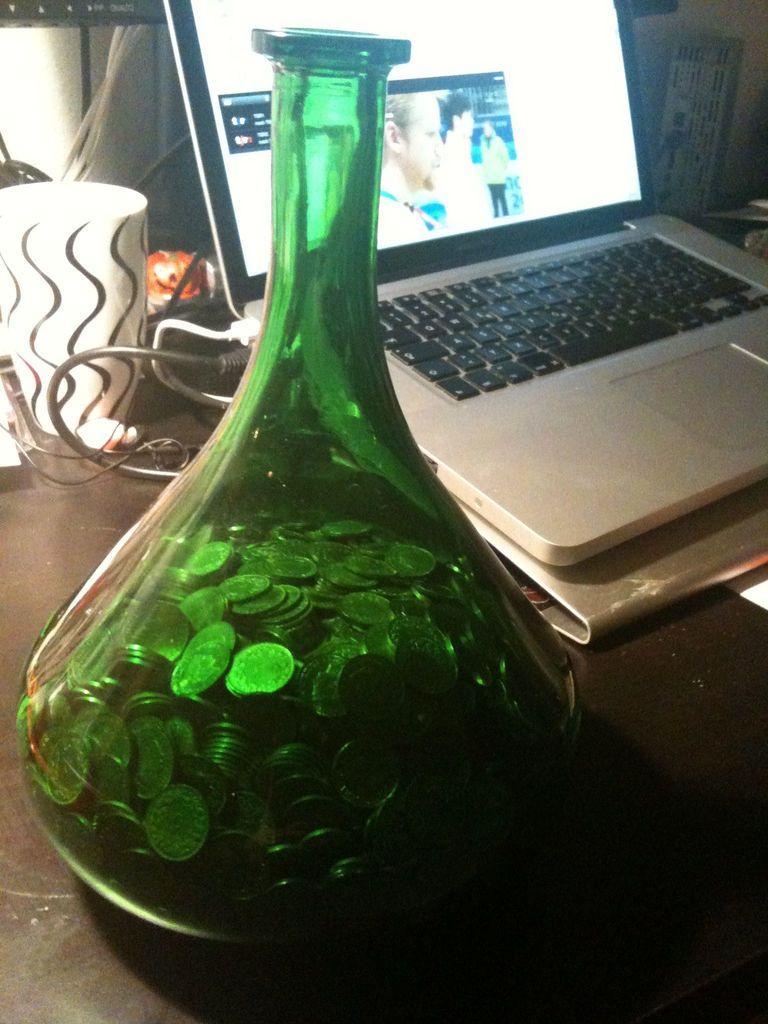Could you give a brief overview of what you see in this image? In the picture we can see a green pot of a glass in that we can see a coins, just beside it we can see a laptop and a screen, and we can also see a white color glass, with some items on a table. 